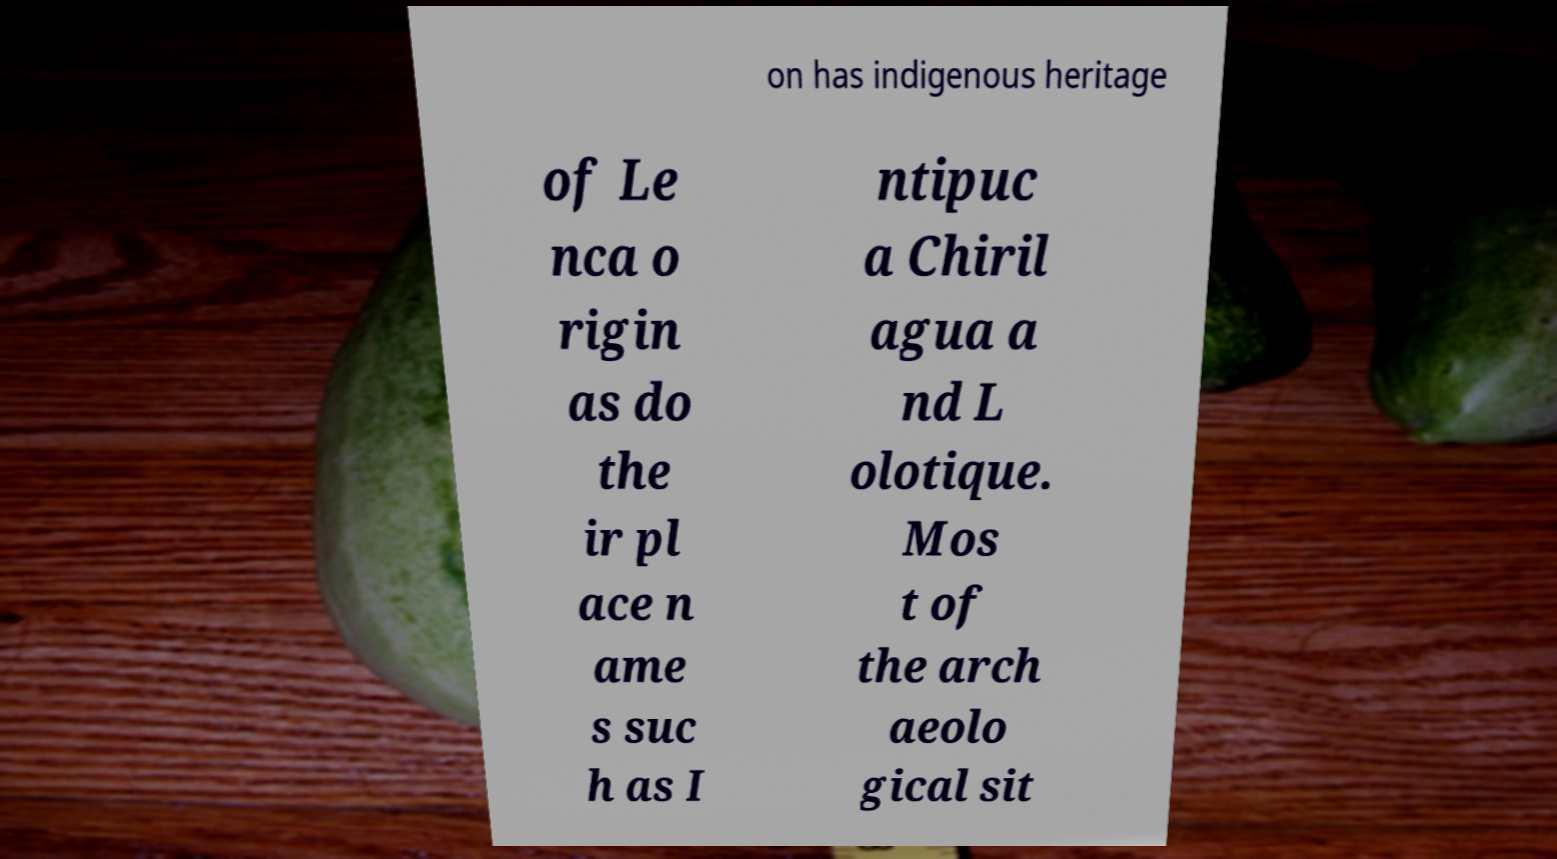Could you assist in decoding the text presented in this image and type it out clearly? on has indigenous heritage of Le nca o rigin as do the ir pl ace n ame s suc h as I ntipuc a Chiril agua a nd L olotique. Mos t of the arch aeolo gical sit 